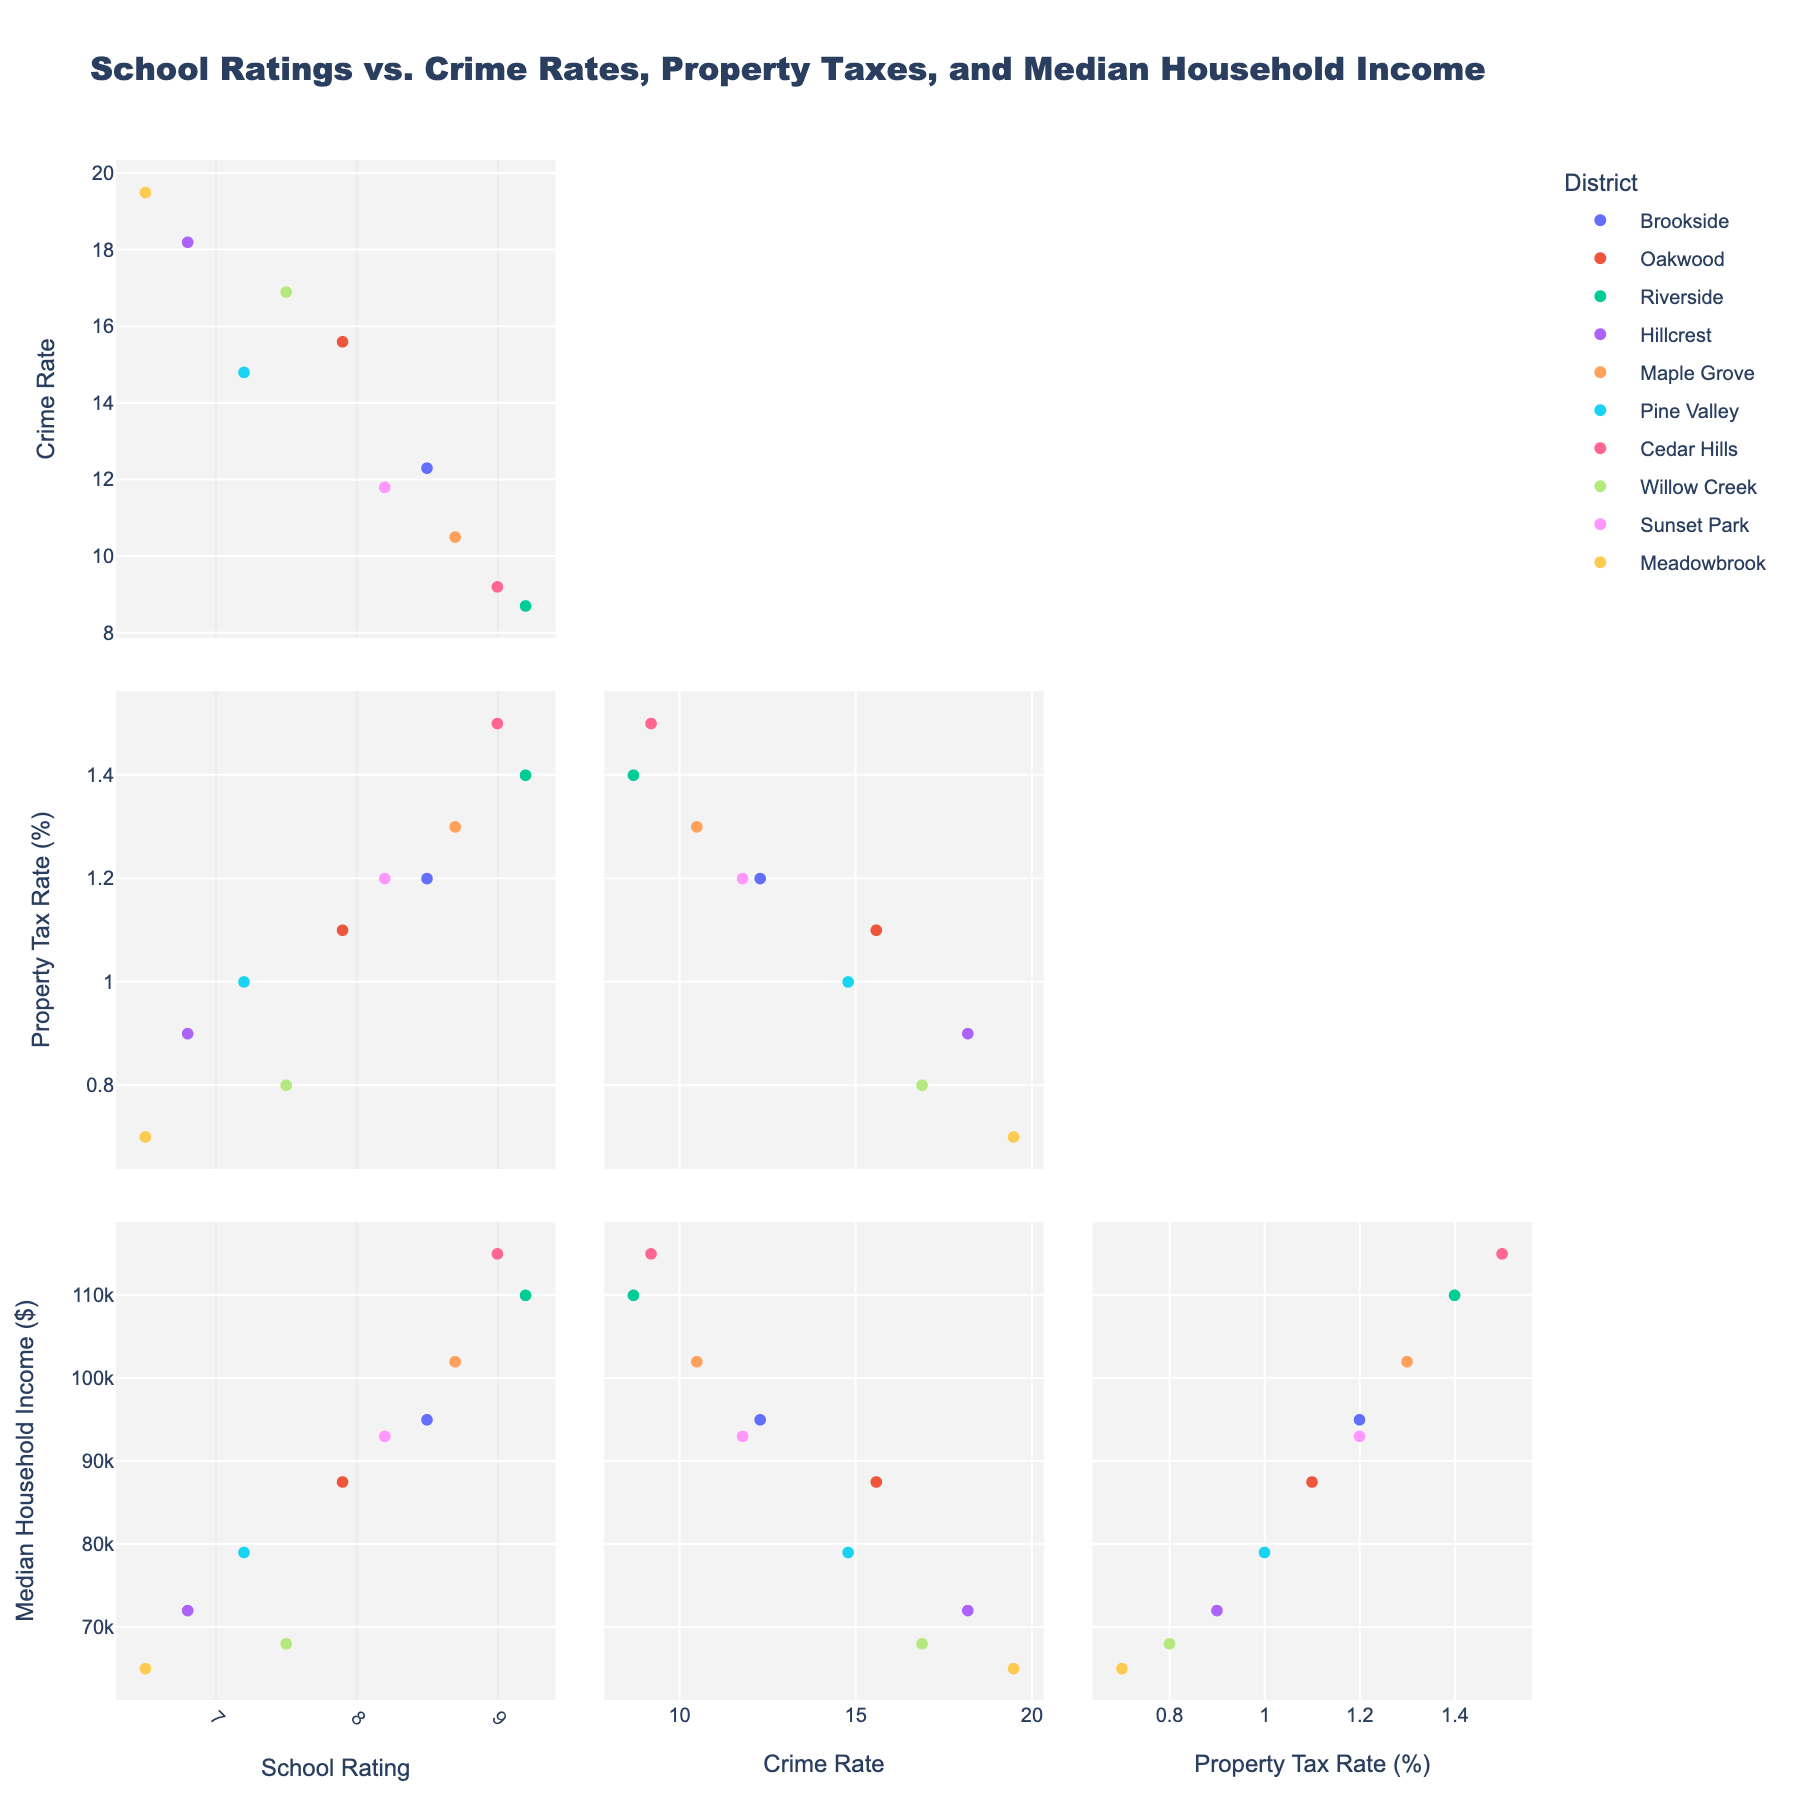What is the title of the plot? The title of the plot is clearly displayed at the top, which reads "Mathematical Puzzles in Bestselling Books".
Answer: Mathematical Puzzles in Bestselling Books Which author has the highest number of Logic Puzzles? To find the author with the highest number of Logic Puzzles, look at the bar labeled "Logic Puzzles" and find the tallest bar. That belongs to Martin Gardner.
Answer: Martin Gardner How many Number Riddles are in "Professor Stewart's Cabinet of Mathematical Curiosities"? For "Professor Stewart's Cabinet of Mathematical Curiosities", look under the category "Number Riddles". The bar value for this book is 28.
Answer: 28 What's the total number of Geometric Challenges in all books combined? Add the values from the "Geometric Challenges" subplot for all authors: 30 (Gardner) + 15 (Stewart) + 20 (Bellos) + 25 (Parker) + 5 (Singh) = 95.
Answer: 95 Compare the frequency of Probability Problems in "Fermat's Last Theorem" and "Alex's Adventures in Numberland". Which book has more? Look at the bar values under "Probability Problems" for both books. Alex's Adventures in Numberland has 25, whereas Fermat's Last Theorem has 30.
Answer: Fermat's Last Theorem Which book features the least amount of Word Math challenges? Look for the shortest bar in the "Word Math" subplot. "Alex's Adventures in Numberland" by Alex Bellos has the shortest bar with a value of 10.
Answer: Alex's Adventures in Numberland What is the most common type of puzzle in "Things to Make and Do in the Fourth Dimension"? In the subplot for "Things to Make and Do in the Fourth Dimension", find the highest bar. The category with the highest count is "Word Math" with 20.
Answer: Word Math Sum the total number of Probability Problems and Word Math challenges in "Hexaflexagons and Other Mathematical Diversions". Add the values for "Probability Problems" (12) and "Word Math" (15) in "Hexaflexagons and Other Mathematical Diversions". The sum is 12 + 15 = 27.
Answer: 27 Which author has the second highest number of Logic Puzzles? Refer to the "Logic Puzzles" subplot and identify the second highest bar. Ian Stewart comes after Martin Gardner, with a value of 20.
Answer: Ian Stewart 